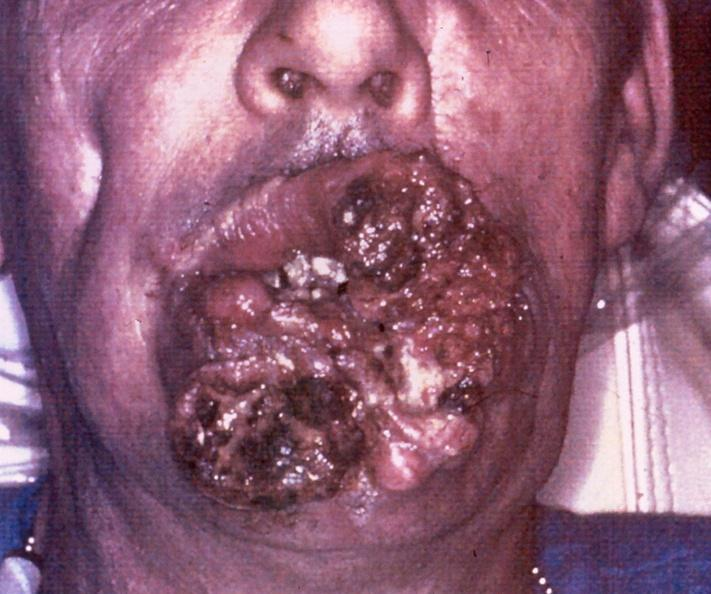does this image show squamous cell carcinoma, lip?
Answer the question using a single word or phrase. Yes 